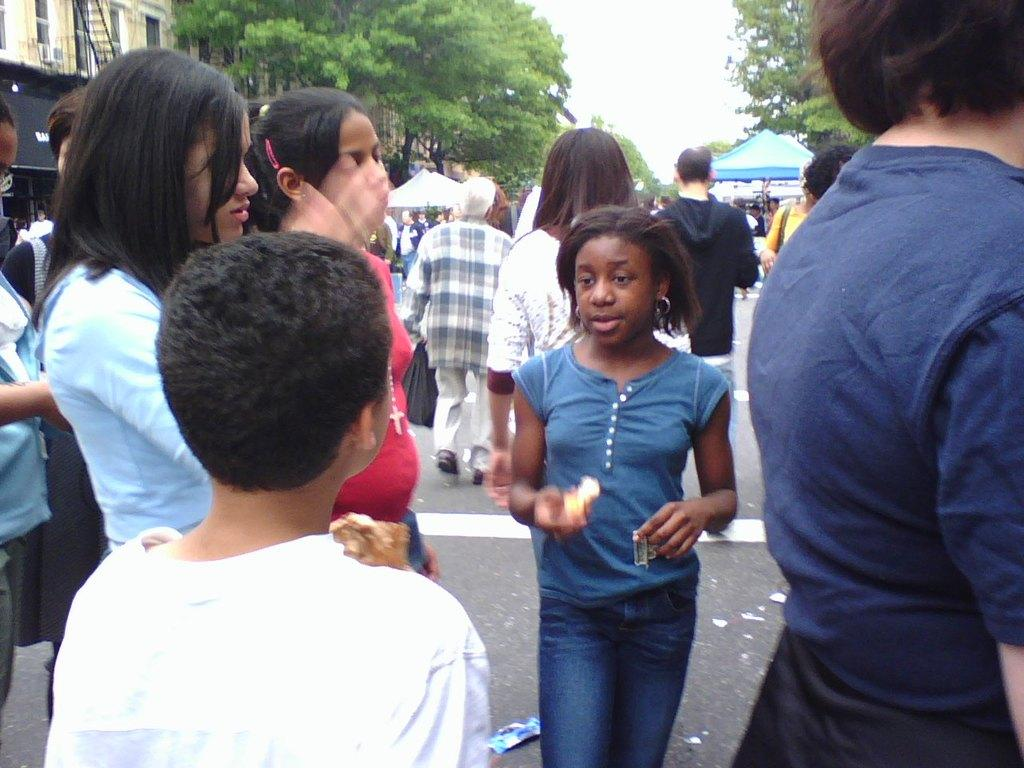How many people are in the image? There are multiple persons in the image. What are the people in the image doing? Some of the persons are standing, while others are walking. What can be seen in the background of the image? There are trees and tents in the background of the image. What structure is located on the left side of the image? There is a building on the left side of the image. What type of advertisement can be seen hanging from the trees in the image? There is no advertisement present in the image. Can you see a kite flying in the sky in the image? There is no kite visible in the image. 